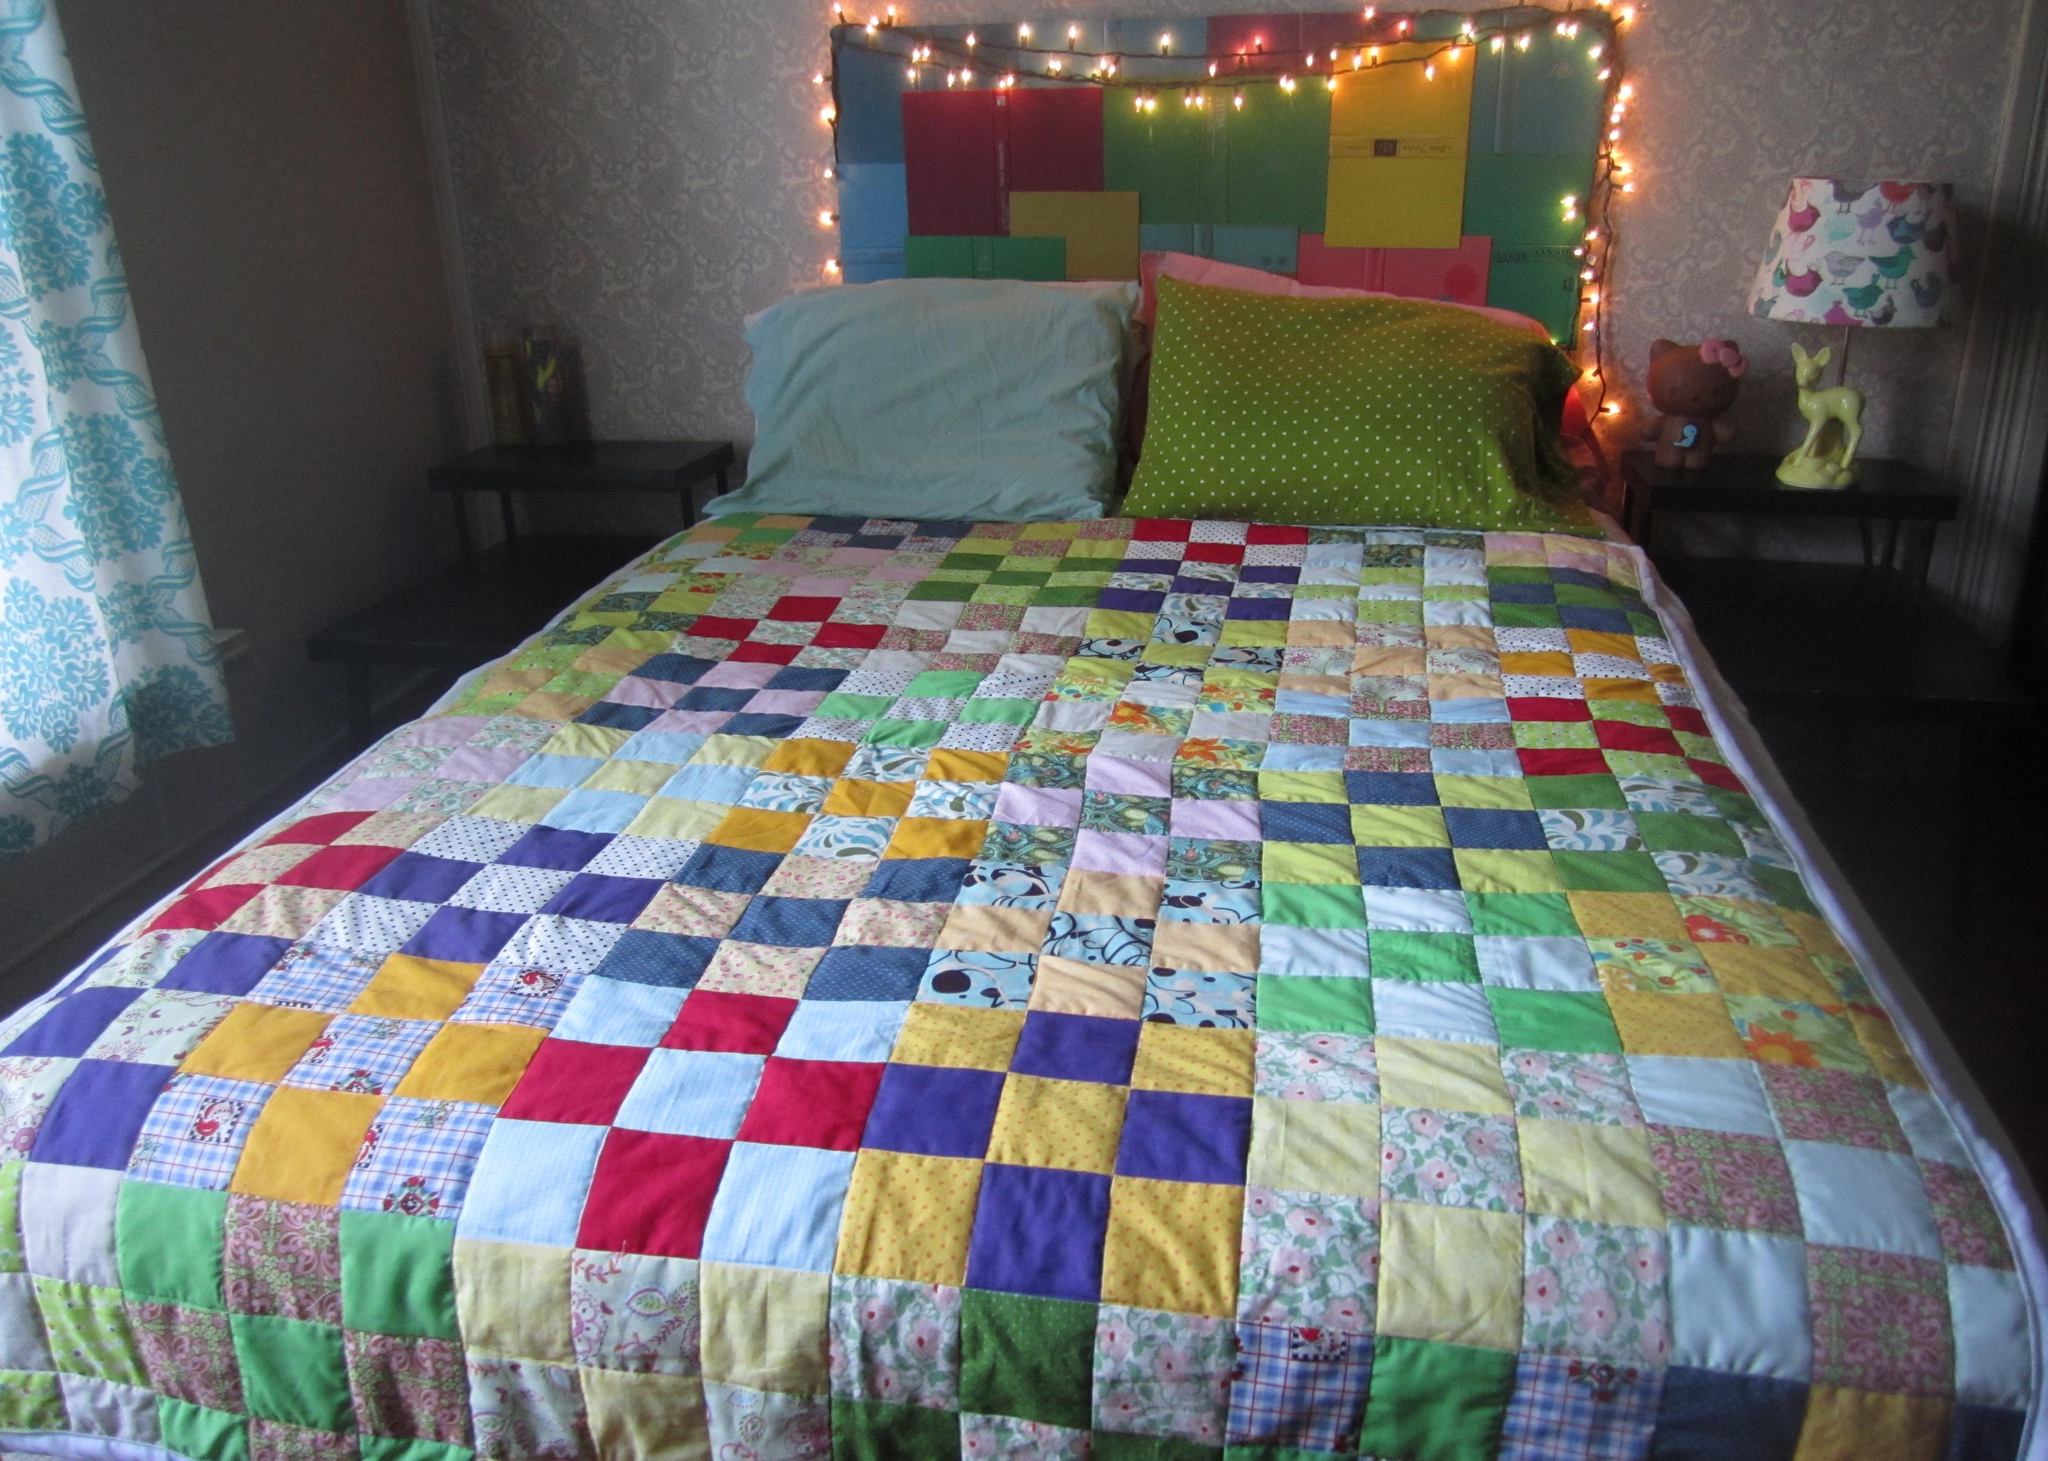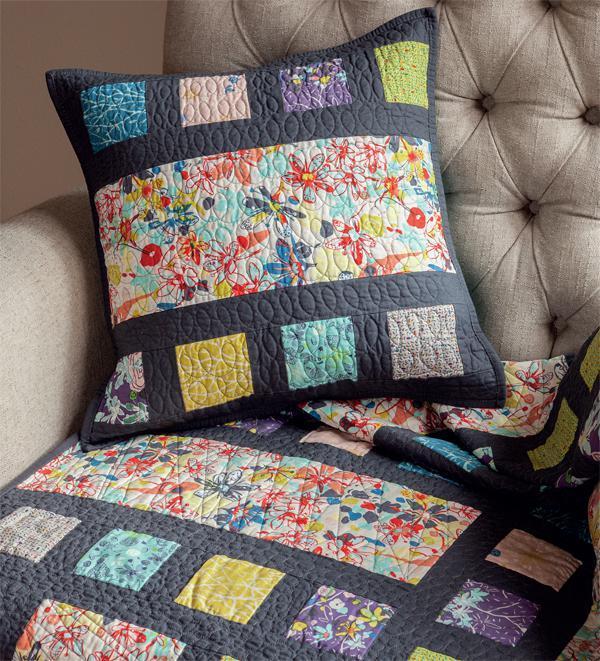The first image is the image on the left, the second image is the image on the right. For the images shown, is this caption "In each of the right photos, there are two children lying on the mattresses." true? Answer yes or no. No. The first image is the image on the left, the second image is the image on the right. Assess this claim about the two images: "there are two children laying on mats on a wood floor". Correct or not? Answer yes or no. No. 